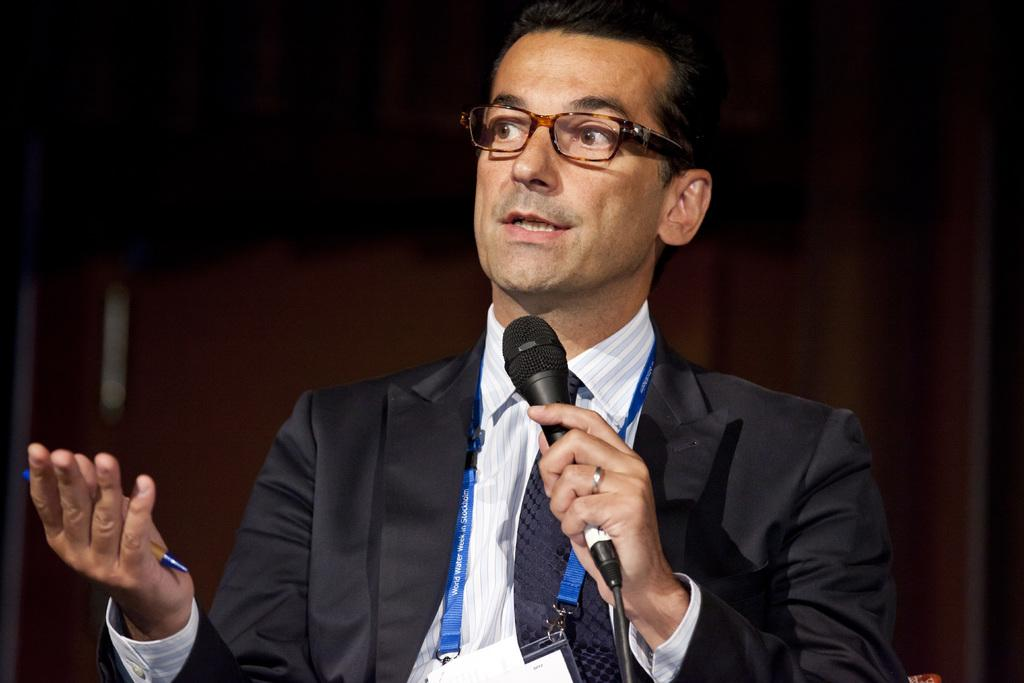What is the person in the image wearing? The person is wearing a black coat in the image. What objects does the person have in their hands? The person has a microphone in one hand and a pen in the other hand. What can be seen in the background of the image? There is a brown curtain in the background of the image. Where is the throne located in the image? There is no throne present in the image. What type of bomb is the person holding in the image? There is no bomb present in the image; the person is holding a microphone and a pen. 